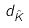<formula> <loc_0><loc_0><loc_500><loc_500>d _ { \hat { K } }</formula> 